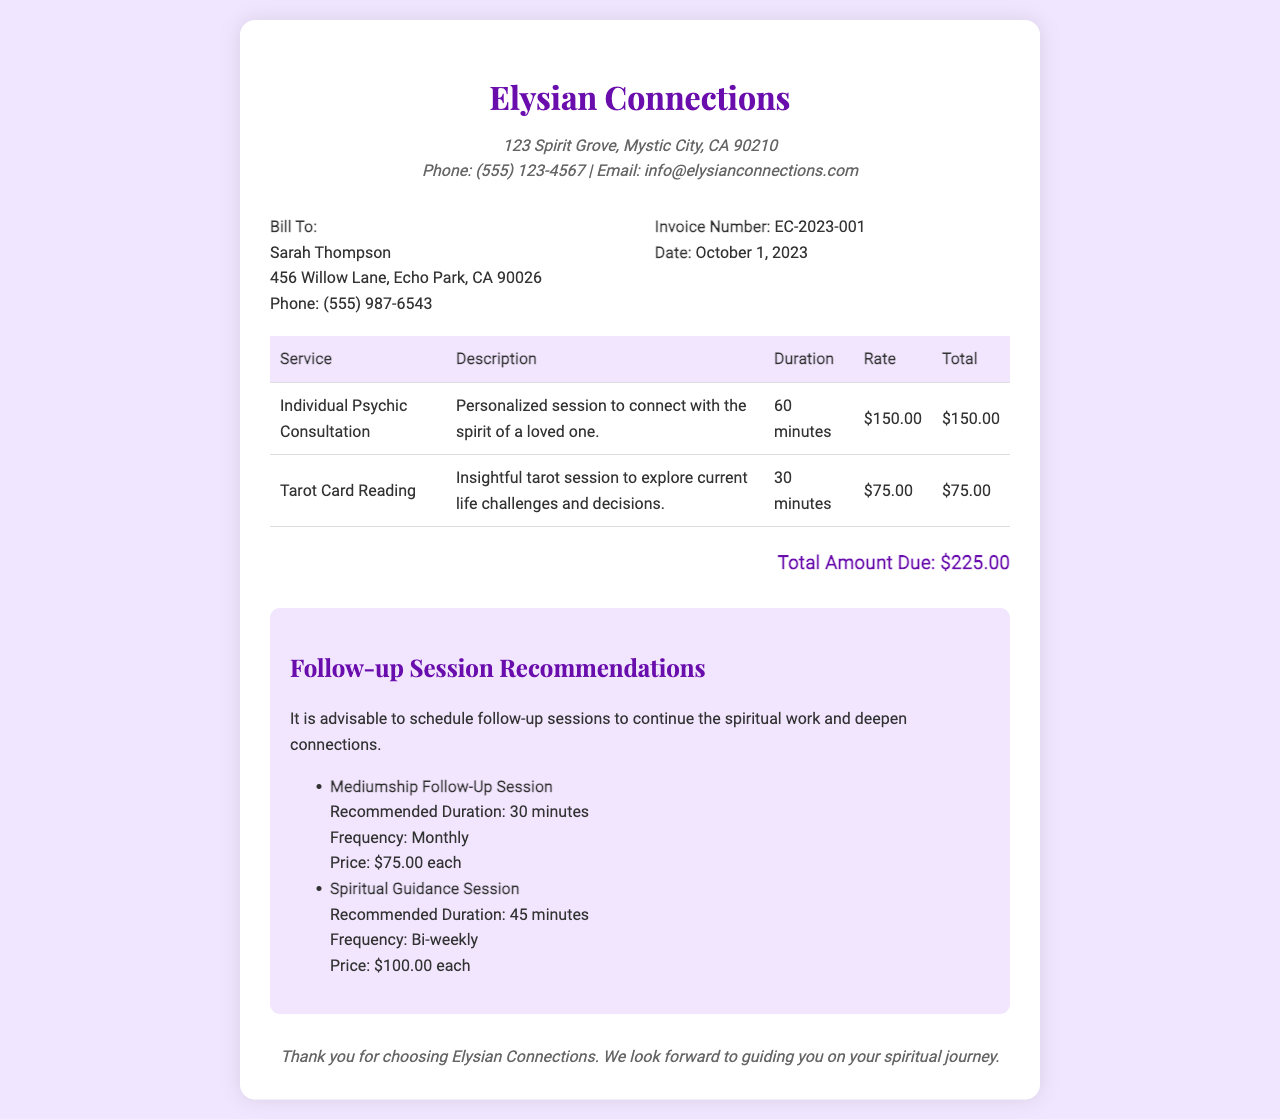what is the invoice number? The invoice number is specified in the document under invoice information, which is EC-2023-001.
Answer: EC-2023-001 who is the client? The client’s name is listed prominently in the billing section of the document, which is Sarah Thompson.
Answer: Sarah Thompson what is the total amount due? The total amount due is presented at the bottom of the invoice, which is $225.00.
Answer: $225.00 how long was the individual psychic consultation? The duration of the individual psychic consultation is detailed in the services table, which is 60 minutes.
Answer: 60 minutes what type of follow-up session is recommended monthly? Recommendations for follow-up sessions are provided in a list, the mediumship follow-up session is suggested for monthly frequency.
Answer: Mediumship Follow-Up Session how much is the rate for a tarot card reading? The rate for each service is listed in the services table; for tarot card reading, it is $75.00.
Answer: $75.00 what is the frequency for spiritual guidance sessions? The frequency of spiritual guidance sessions is mentioned in the recommendations section as bi-weekly.
Answer: Bi-weekly where is Elysian Connections located? The business address is included in the header, which is 123 Spirit Grove, Mystic City, CA 90210.
Answer: 123 Spirit Grove, Mystic City, CA 90210 what is the duration for the recommended mediumship follow-up session? The recommended duration for the mediumship follow-up session can be found in the recommendations, which is 30 minutes.
Answer: 30 minutes 